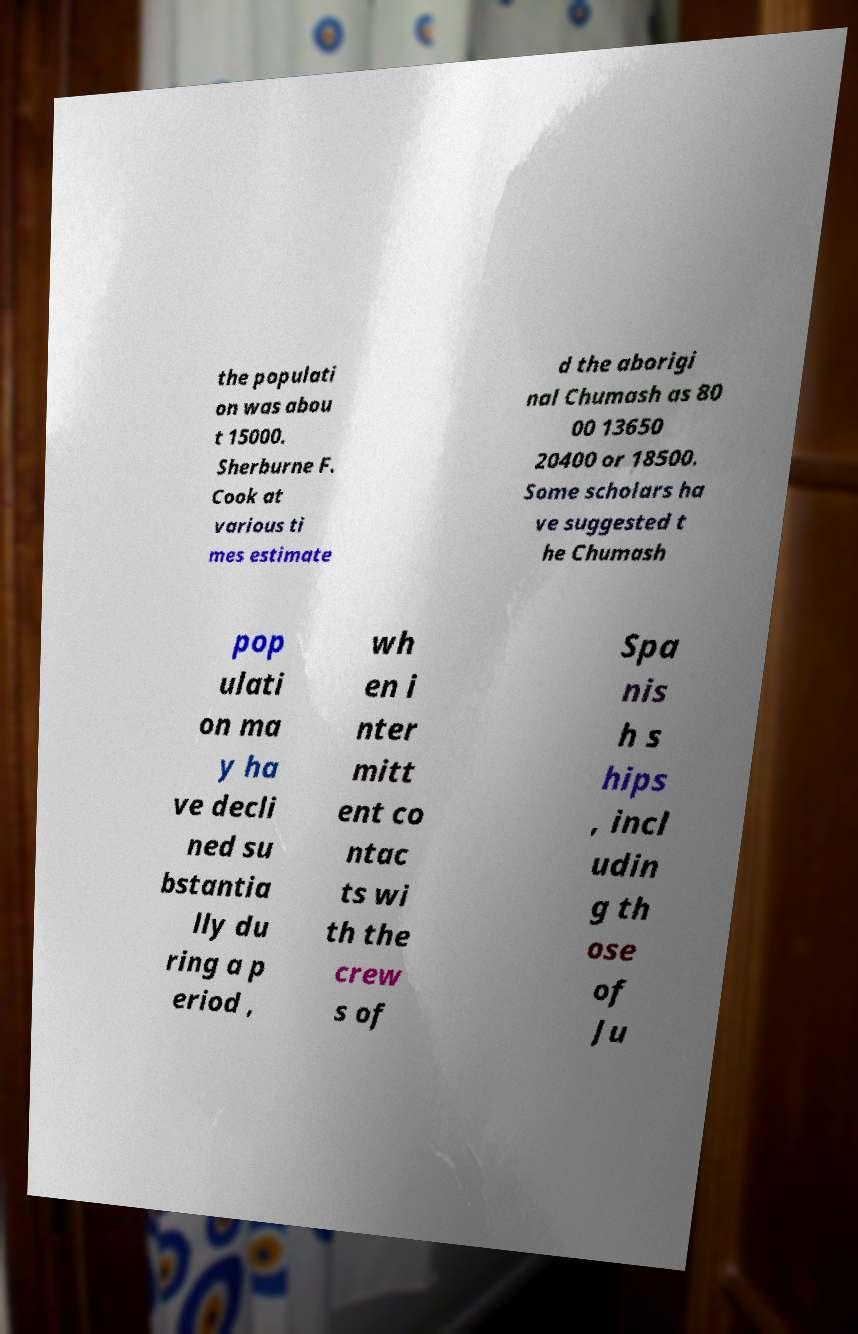There's text embedded in this image that I need extracted. Can you transcribe it verbatim? the populati on was abou t 15000. Sherburne F. Cook at various ti mes estimate d the aborigi nal Chumash as 80 00 13650 20400 or 18500. Some scholars ha ve suggested t he Chumash pop ulati on ma y ha ve decli ned su bstantia lly du ring a p eriod , wh en i nter mitt ent co ntac ts wi th the crew s of Spa nis h s hips , incl udin g th ose of Ju 